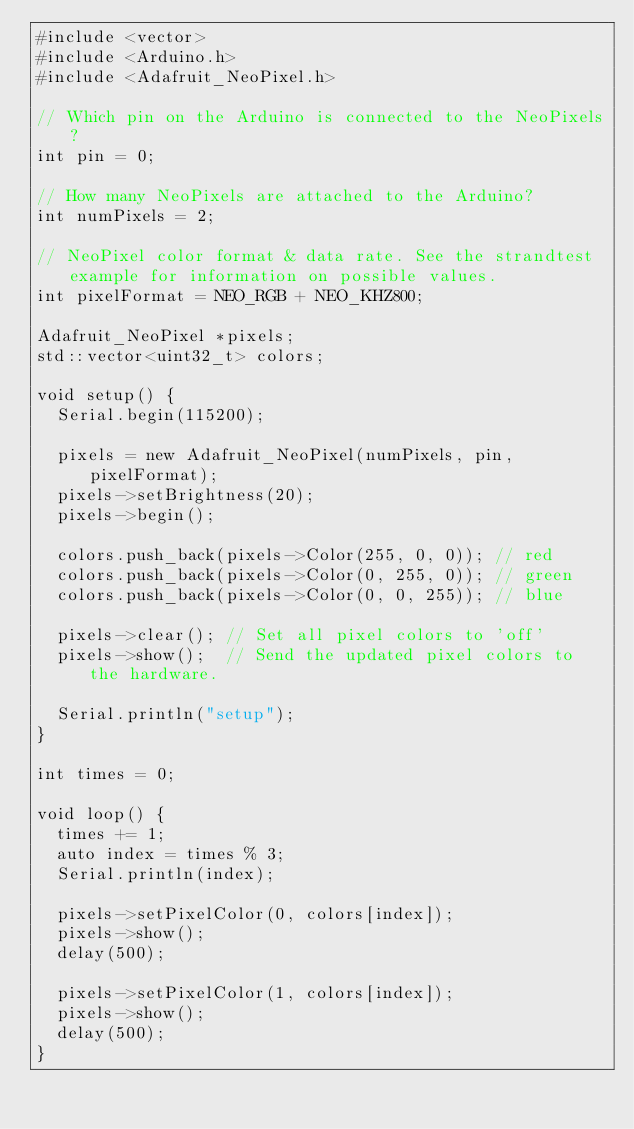Convert code to text. <code><loc_0><loc_0><loc_500><loc_500><_C++_>#include <vector>
#include <Arduino.h>
#include <Adafruit_NeoPixel.h>

// Which pin on the Arduino is connected to the NeoPixels?
int pin = 0;

// How many NeoPixels are attached to the Arduino?
int numPixels = 2;

// NeoPixel color format & data rate. See the strandtest example for information on possible values.
int pixelFormat = NEO_RGB + NEO_KHZ800;

Adafruit_NeoPixel *pixels;
std::vector<uint32_t> colors;

void setup() {
  Serial.begin(115200);

  pixels = new Adafruit_NeoPixel(numPixels, pin, pixelFormat);
  pixels->setBrightness(20);
  pixels->begin();

  colors.push_back(pixels->Color(255, 0, 0)); // red
  colors.push_back(pixels->Color(0, 255, 0)); // green
  colors.push_back(pixels->Color(0, 0, 255)); // blue

  pixels->clear(); // Set all pixel colors to 'off'
  pixels->show();  // Send the updated pixel colors to the hardware.

  Serial.println("setup");
}

int times = 0;

void loop() {
  times += 1;
  auto index = times % 3;
  Serial.println(index);

  pixels->setPixelColor(0, colors[index]);
  pixels->show();
  delay(500);

  pixels->setPixelColor(1, colors[index]);
  pixels->show();
  delay(500);
}
</code> 